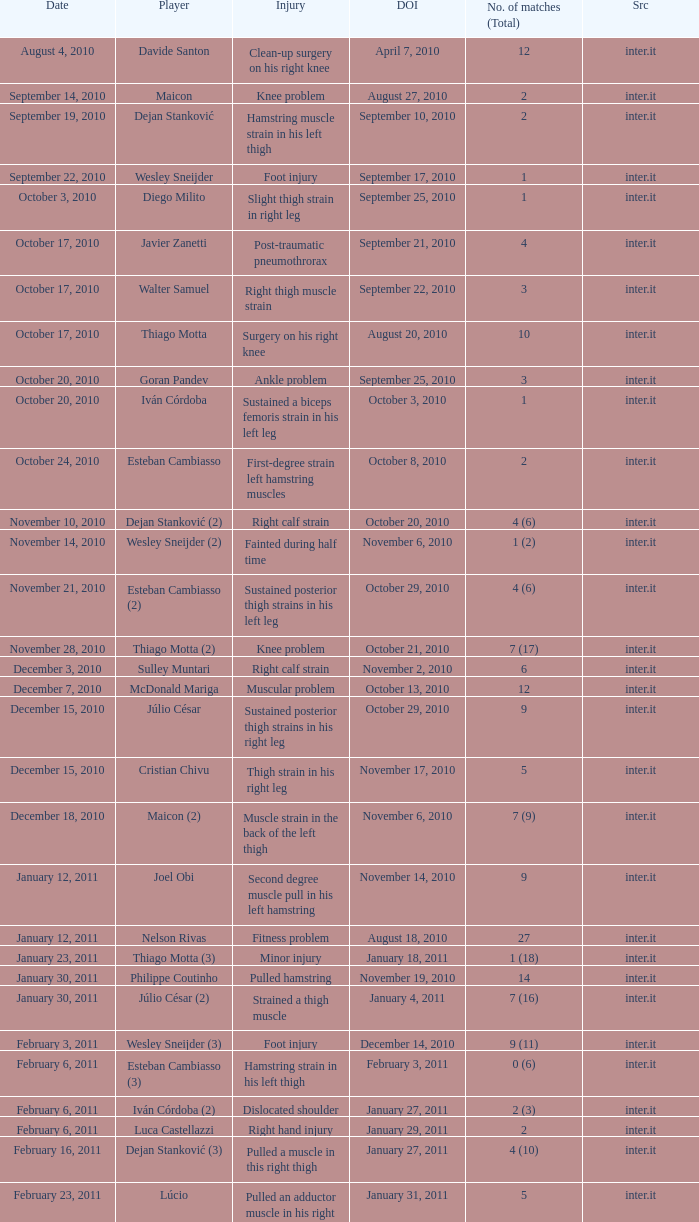What is the date of injury when the injury is foot injury and the number of matches (total) is 1? September 17, 2010. 